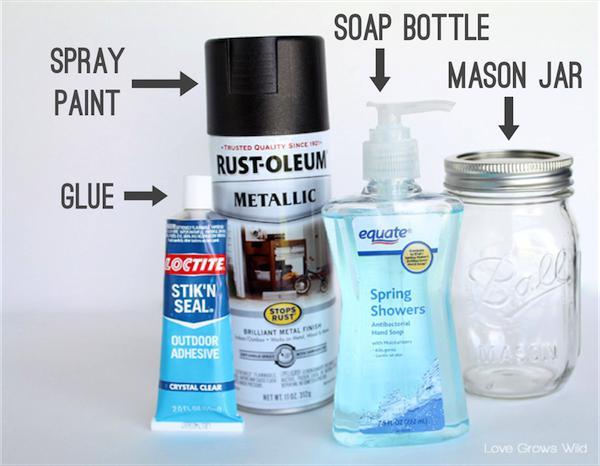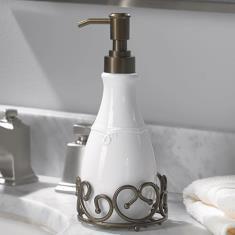The first image is the image on the left, the second image is the image on the right. Assess this claim about the two images: "One image shows a single pump-top dispenser, which is opaque white and has a left-facing nozzle.". Correct or not? Answer yes or no. Yes. The first image is the image on the left, the second image is the image on the right. Analyze the images presented: Is the assertion "There are more containers in the image on the left." valid? Answer yes or no. Yes. 